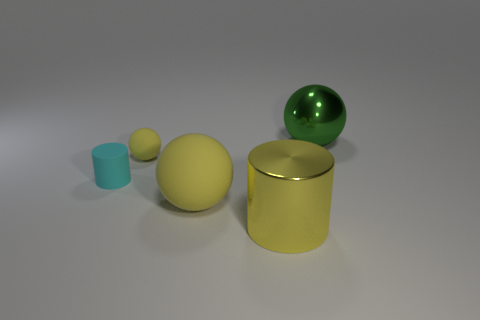Is the number of yellow metal cylinders that are behind the metal sphere less than the number of small blue spheres?
Your answer should be very brief. No. How many matte things are there?
Keep it short and to the point. 3. What number of big yellow objects are the same material as the big green object?
Ensure brevity in your answer.  1. How many objects are either yellow things that are behind the cyan rubber cylinder or tiny gray matte balls?
Your answer should be compact. 1. Are there fewer large metal spheres in front of the small matte ball than yellow cylinders that are behind the large shiny cylinder?
Offer a terse response. No. Are there any large green shiny balls behind the cyan matte object?
Keep it short and to the point. Yes. How many objects are either rubber objects that are to the right of the cyan cylinder or big yellow things that are left of the big yellow metal cylinder?
Your answer should be compact. 2. How many large matte balls have the same color as the small sphere?
Provide a succinct answer. 1. The other big thing that is the same shape as the green thing is what color?
Give a very brief answer. Yellow. What is the shape of the thing that is both behind the small cyan cylinder and on the left side of the big metal sphere?
Your answer should be very brief. Sphere. 